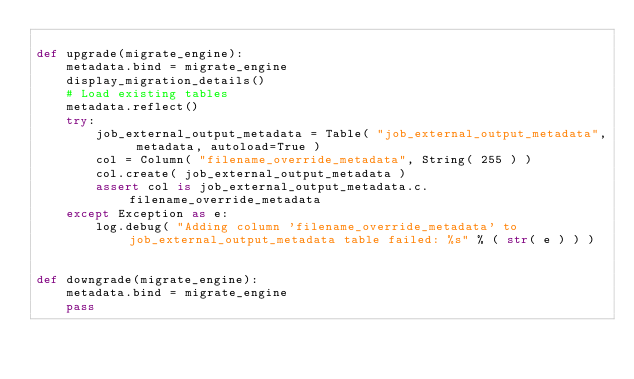Convert code to text. <code><loc_0><loc_0><loc_500><loc_500><_Python_>
def upgrade(migrate_engine):
    metadata.bind = migrate_engine
    display_migration_details()
    # Load existing tables
    metadata.reflect()
    try:
        job_external_output_metadata = Table( "job_external_output_metadata", metadata, autoload=True )
        col = Column( "filename_override_metadata", String( 255 ) )
        col.create( job_external_output_metadata )
        assert col is job_external_output_metadata.c.filename_override_metadata
    except Exception as e:
        log.debug( "Adding column 'filename_override_metadata' to job_external_output_metadata table failed: %s" % ( str( e ) ) )


def downgrade(migrate_engine):
    metadata.bind = migrate_engine
    pass
</code> 